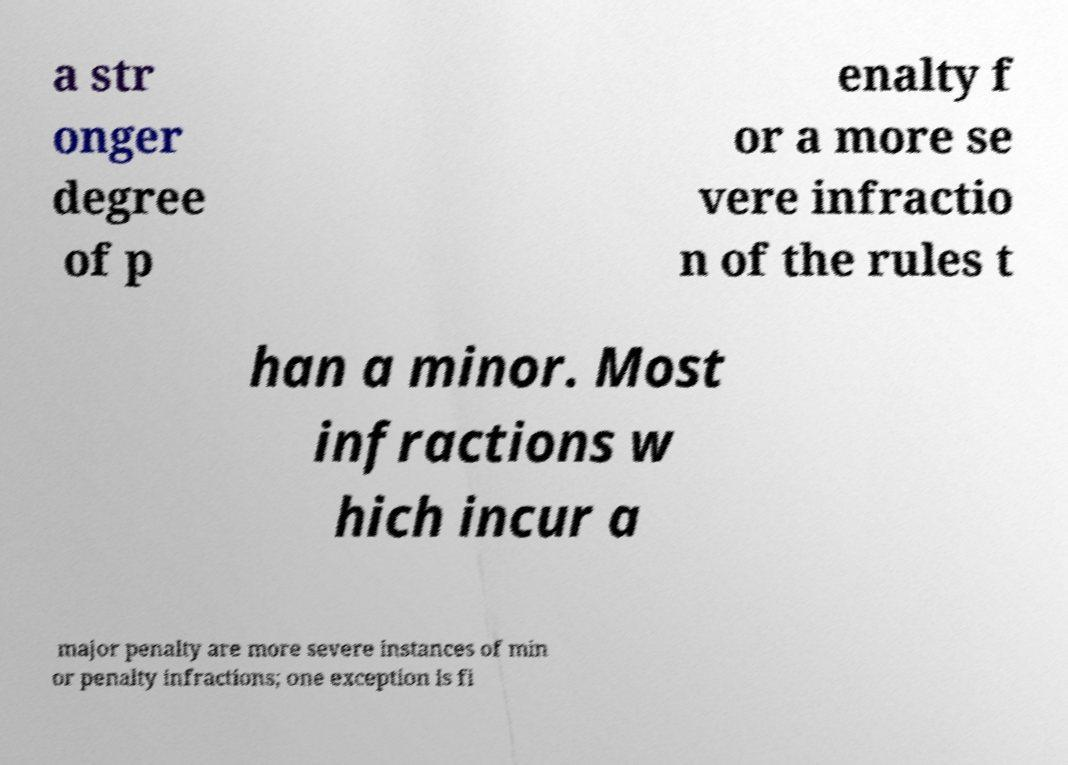For documentation purposes, I need the text within this image transcribed. Could you provide that? a str onger degree of p enalty f or a more se vere infractio n of the rules t han a minor. Most infractions w hich incur a major penalty are more severe instances of min or penalty infractions; one exception is fi 